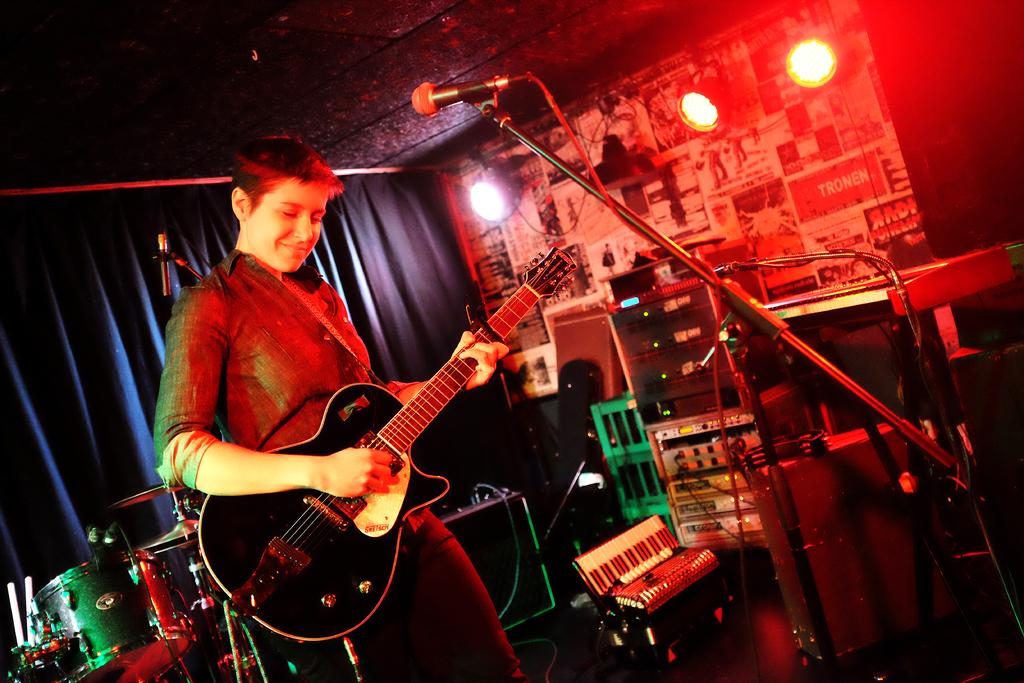Who is the main subject in the image? There is a person in the image. What is the person doing in the image? The person is playing a guitar. What object is in front of the person? The person is in front of a microphone. What else can be seen in the image related to music? There are musical instruments behind the person. Can you see any trains in the image? No, there are no trains present in the image. What type of hole is visible in the image? There is no hole visible in the image. 